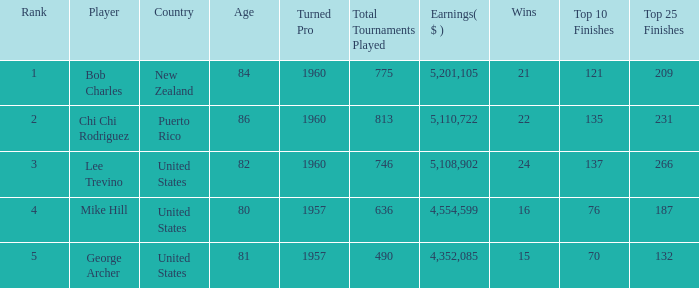What is the lowest level of Earnings($) to have a Wins value of 22 and a Rank lower than 2? None. 